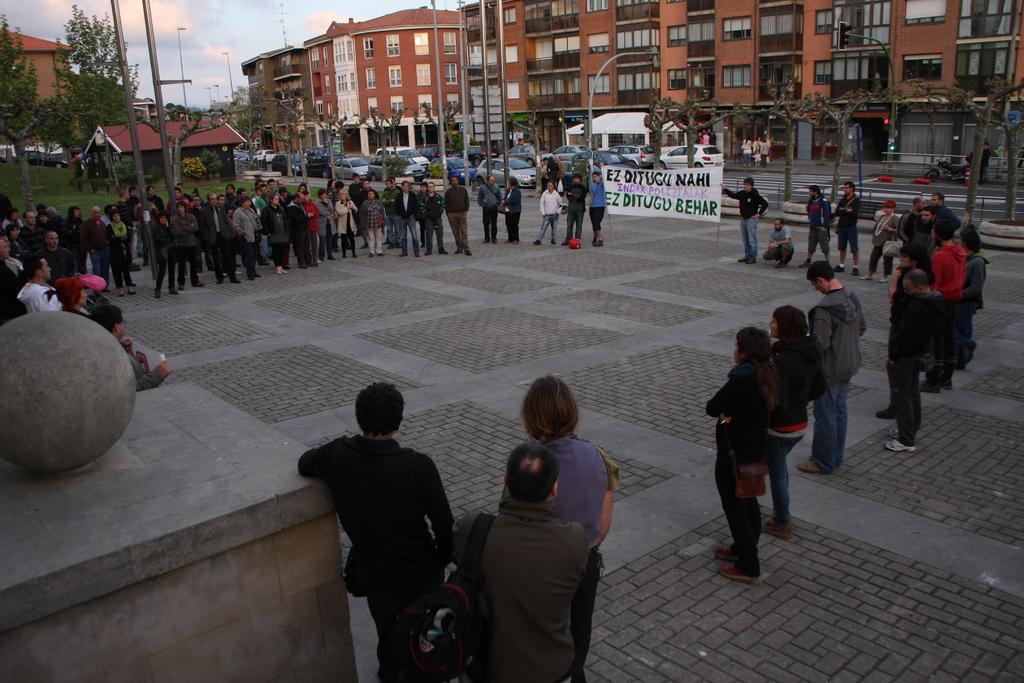Could you give a brief overview of what you see in this image? In the picture I can see a group of people standing on the side of the road and they are having a discussion. I can see the banner on the side of the road. In the background, I can see the buildings and vehicles on the road. I can see the traffic signal pole and light poles on the side of the road. There are trees on the top left side of the picture. There are clouds in the sky. 